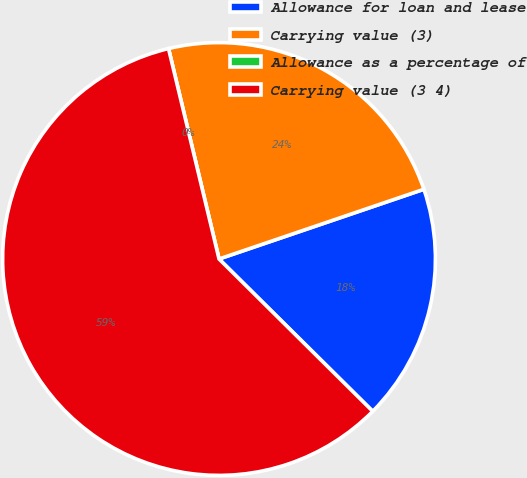Convert chart. <chart><loc_0><loc_0><loc_500><loc_500><pie_chart><fcel>Allowance for loan and lease<fcel>Carrying value (3)<fcel>Allowance as a percentage of<fcel>Carrying value (3 4)<nl><fcel>17.65%<fcel>23.53%<fcel>0.0%<fcel>58.82%<nl></chart> 